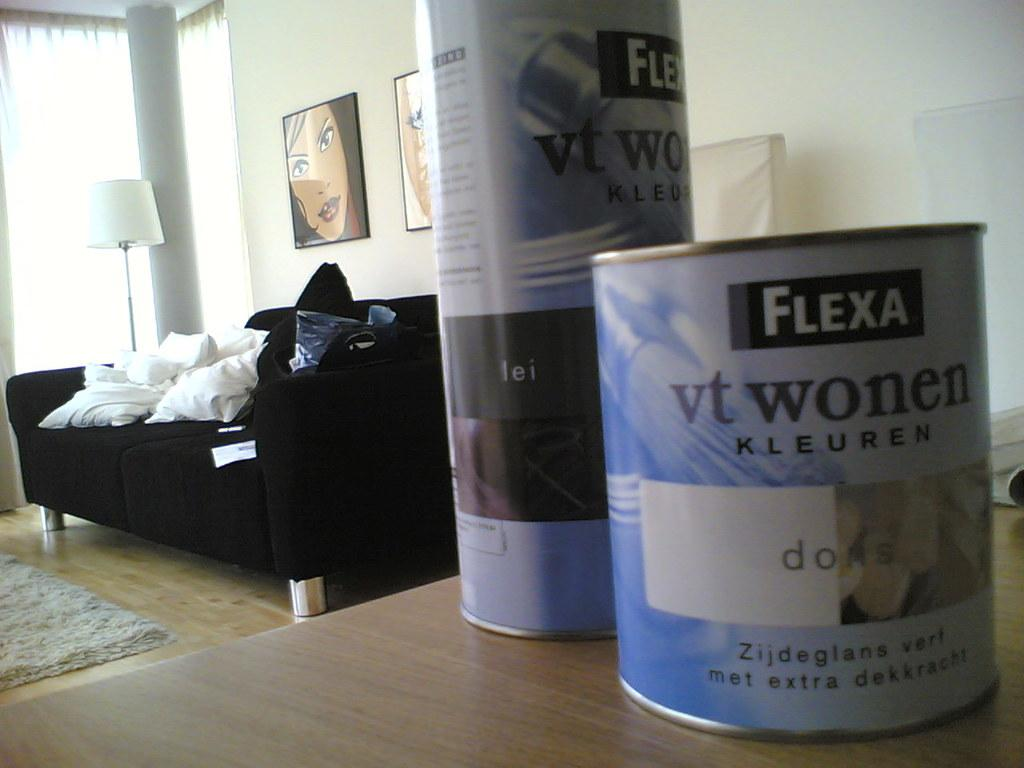<image>
Share a concise interpretation of the image provided. A livingroom with a table that has 2 cans of something called Flexa on it. 